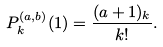Convert formula to latex. <formula><loc_0><loc_0><loc_500><loc_500>P _ { k } ^ { ( a , b ) } ( 1 ) = \frac { ( a + 1 ) _ { k } } { k ! } .</formula> 